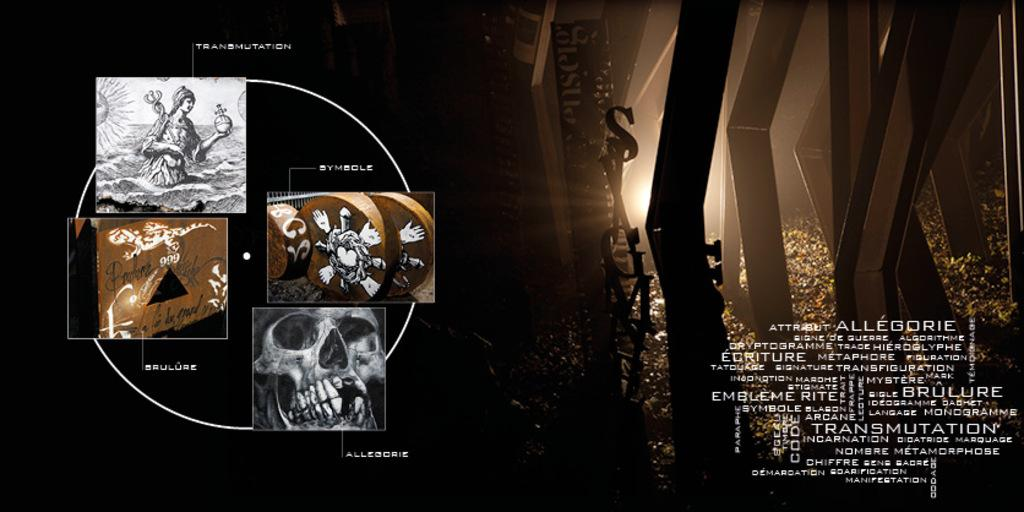<image>
Present a compact description of the photo's key features. Many sepia and black and white images are surrounded by text such as "transmutation". 